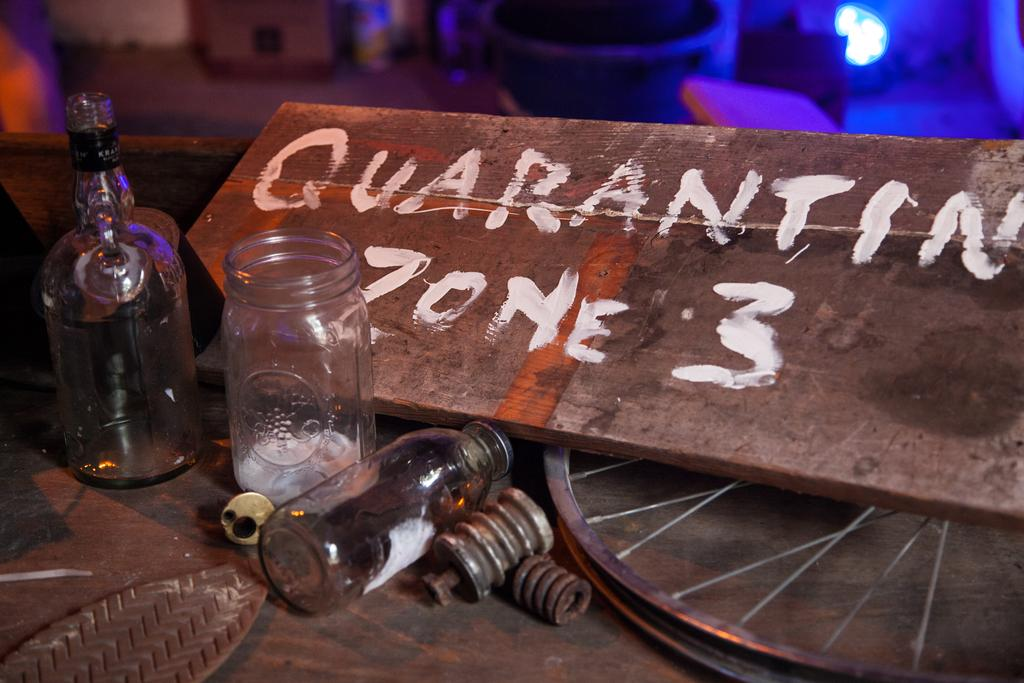What objects are located in the center of the image? There are bottles in the center of the image. What is written on the wood material in the image? "Zone 3" is written on the wood material in the image. Where is the wheel positioned in the image? The wheel is at the bottom of the image. What type of flag is flying in the garden in the image? There is no flag or garden present in the image. 